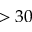Convert formula to latex. <formula><loc_0><loc_0><loc_500><loc_500>> 3 0</formula> 